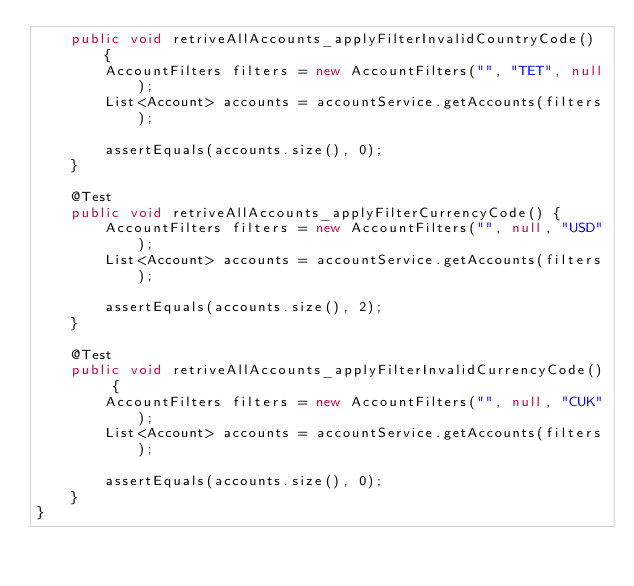<code> <loc_0><loc_0><loc_500><loc_500><_Java_>	public void retriveAllAccounts_applyFilterInvalidCountryCode() {
		AccountFilters filters = new AccountFilters("", "TET", null);
		List<Account> accounts = accountService.getAccounts(filters);
		
		assertEquals(accounts.size(), 0);
	}
	
	@Test
	public void retriveAllAccounts_applyFilterCurrencyCode() {
		AccountFilters filters = new AccountFilters("", null, "USD");
		List<Account> accounts = accountService.getAccounts(filters);
		
		assertEquals(accounts.size(), 2);
	}
	
	@Test
	public void retriveAllAccounts_applyFilterInvalidCurrencyCode() {
		AccountFilters filters = new AccountFilters("", null, "CUK");
		List<Account> accounts = accountService.getAccounts(filters);
		
		assertEquals(accounts.size(), 0);
	}
}
</code> 